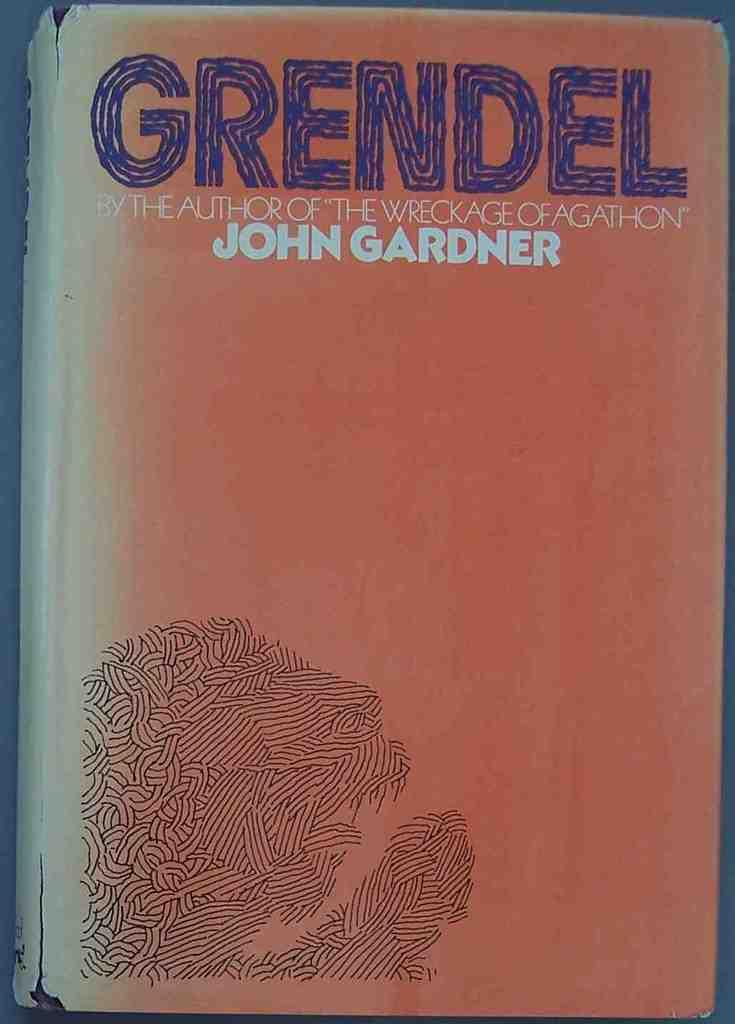<image>
Provide a brief description of the given image. The bookcover for Grendel by the author of The Wreckage of Agathon, John Gardner is shown. 